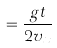<formula> <loc_0><loc_0><loc_500><loc_500>= \frac { g t } { 2 v _ { x } }</formula> 